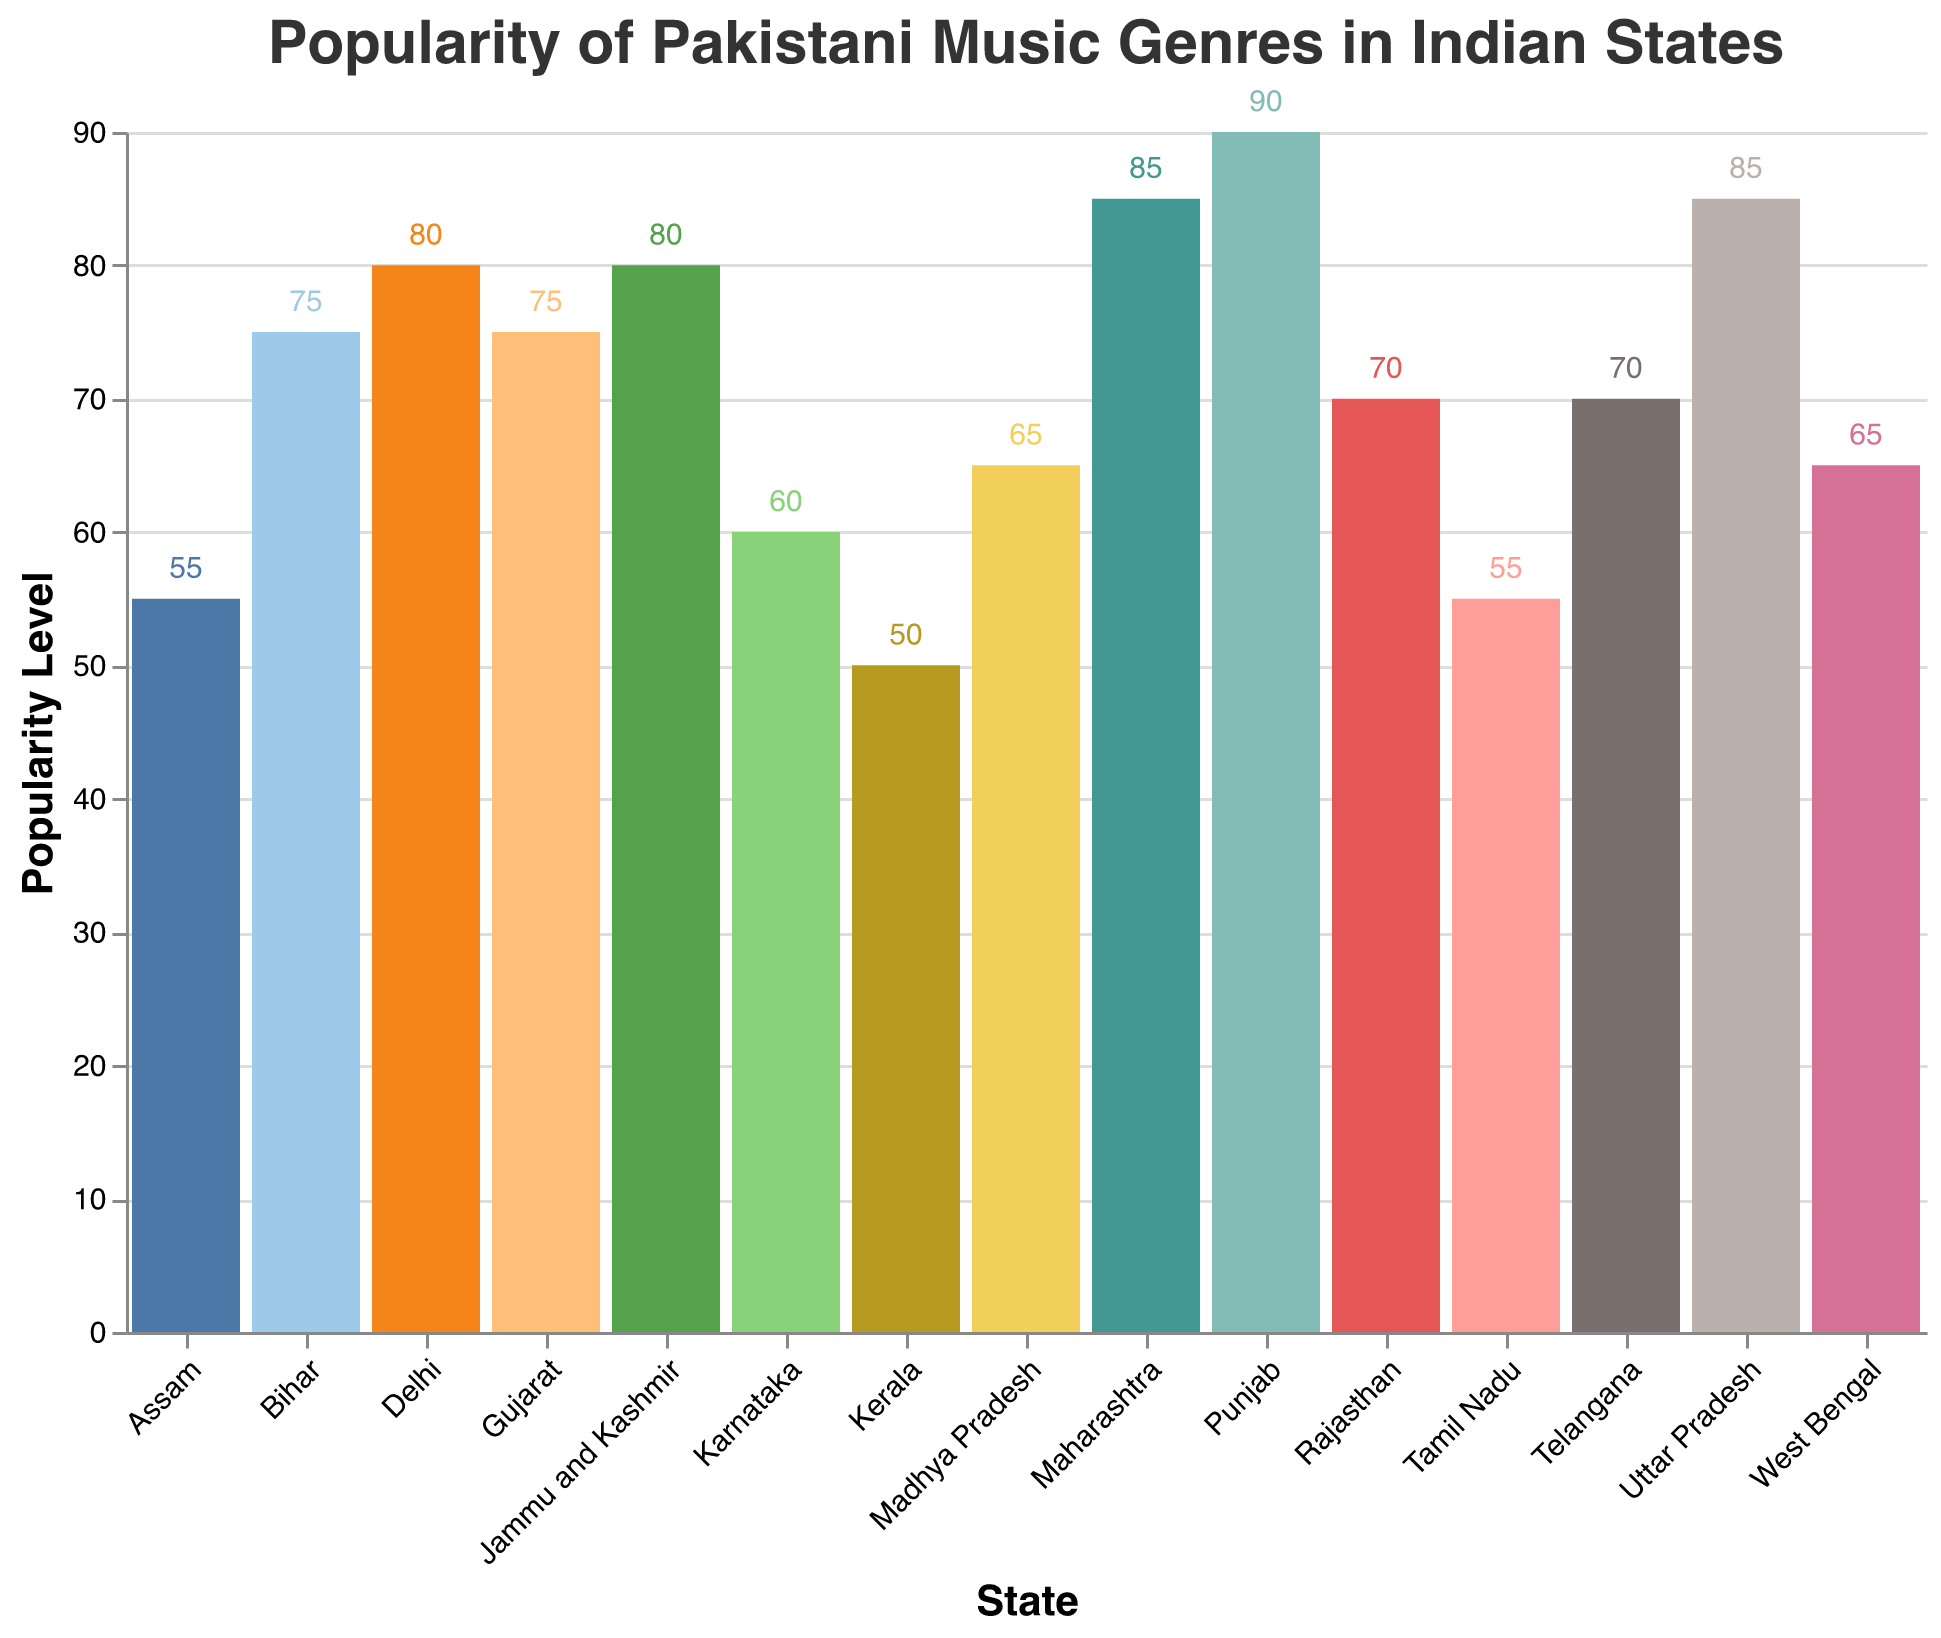Which state shows the highest popularity for Qawwali music? Looking at the figure, identify the state with the tallest bar for Qawwali music. The highest value for Qawwali is 90, which corresponds to Punjab.
Answer: Punjab Which state has the lowest popularity for Pop music? Check the Pop values for all states and find the smallest number. Kerala shows the lowest popularity for Pop music with a value of 35.
Answer: Kerala What is the average popularity level of Sufi Rock across all states? Sum the Sufi Rock values for all states (55, 65, 60, 50, 45, 55, 40, 45, 35, 60, 50, 45, 40, 30, 35), then divide by the number of states (15). The total is 720, so the average is 720 / 15.
Answer: 48 Which music genre is the least popular in Karnataka? Look at the values for Qawwali, Ghazal, Sufi Rock, and Pop in Karnataka. The least popular genre is Ghazal, with a value of 50.
Answer: Ghazal What states have a Qawwali popularity score above 80? Find the states where the Qawwali value is greater than 80. These states are Maharashtra, Punjab, Delhi, Uttar Pradesh, and Jammu and Kashmir.
Answer: Maharashtra, Punjab, Delhi, Uttar Pradesh, Jammu and Kashmir 